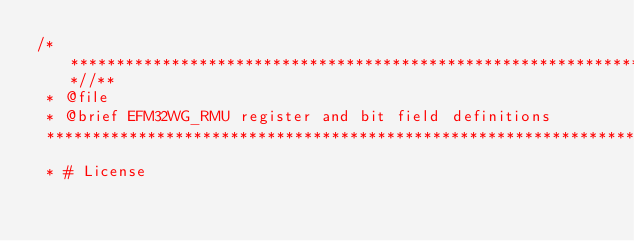Convert code to text. <code><loc_0><loc_0><loc_500><loc_500><_C_>/***************************************************************************//**
 * @file
 * @brief EFM32WG_RMU register and bit field definitions
 *******************************************************************************
 * # License</code> 